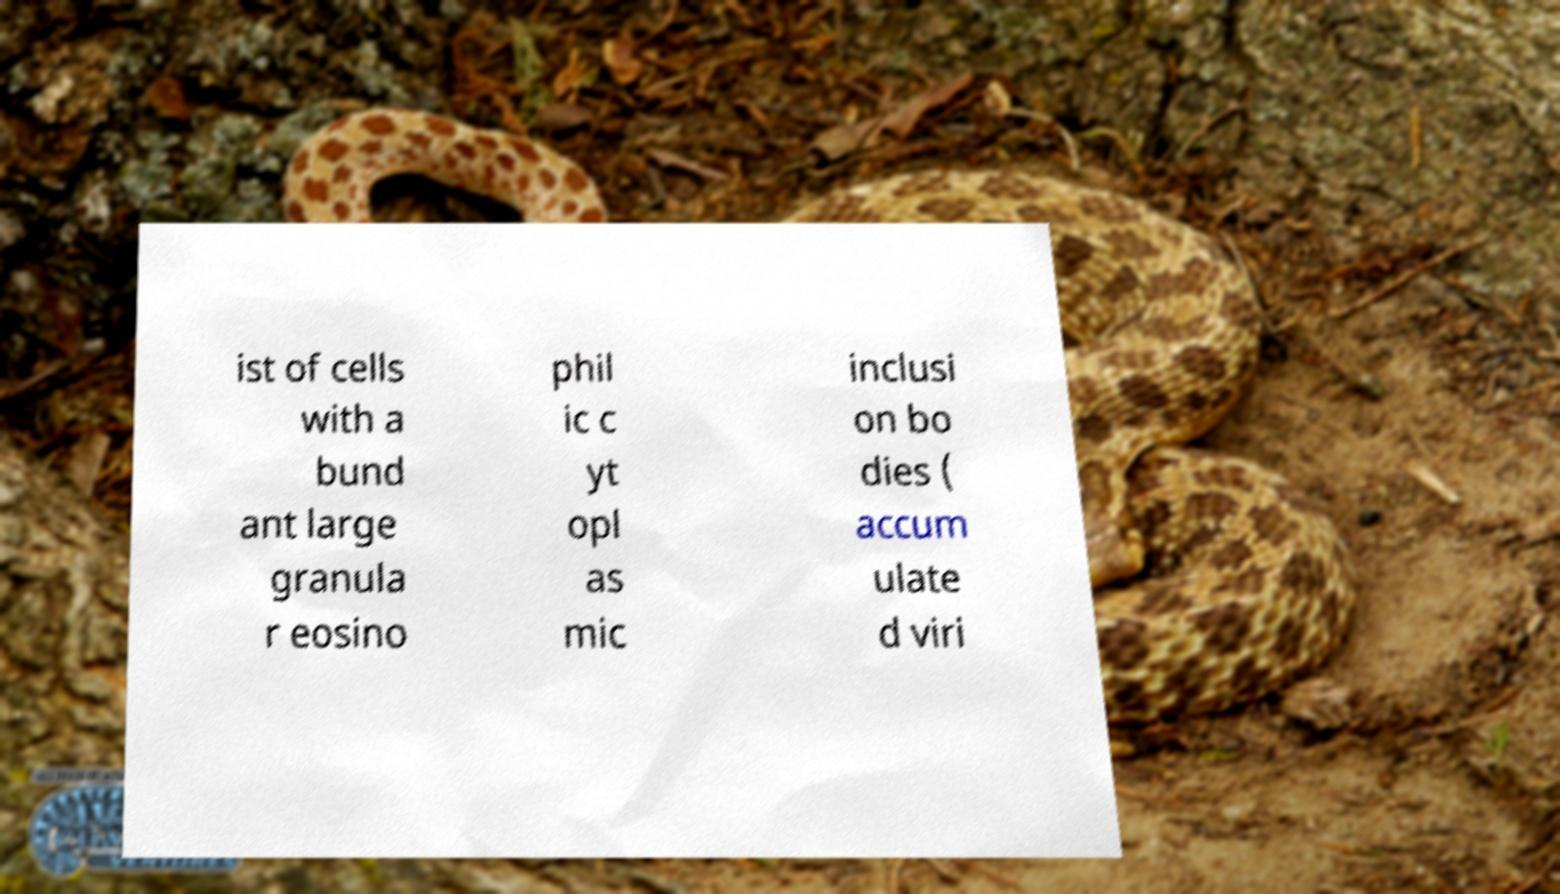Please identify and transcribe the text found in this image. ist of cells with a bund ant large granula r eosino phil ic c yt opl as mic inclusi on bo dies ( accum ulate d viri 